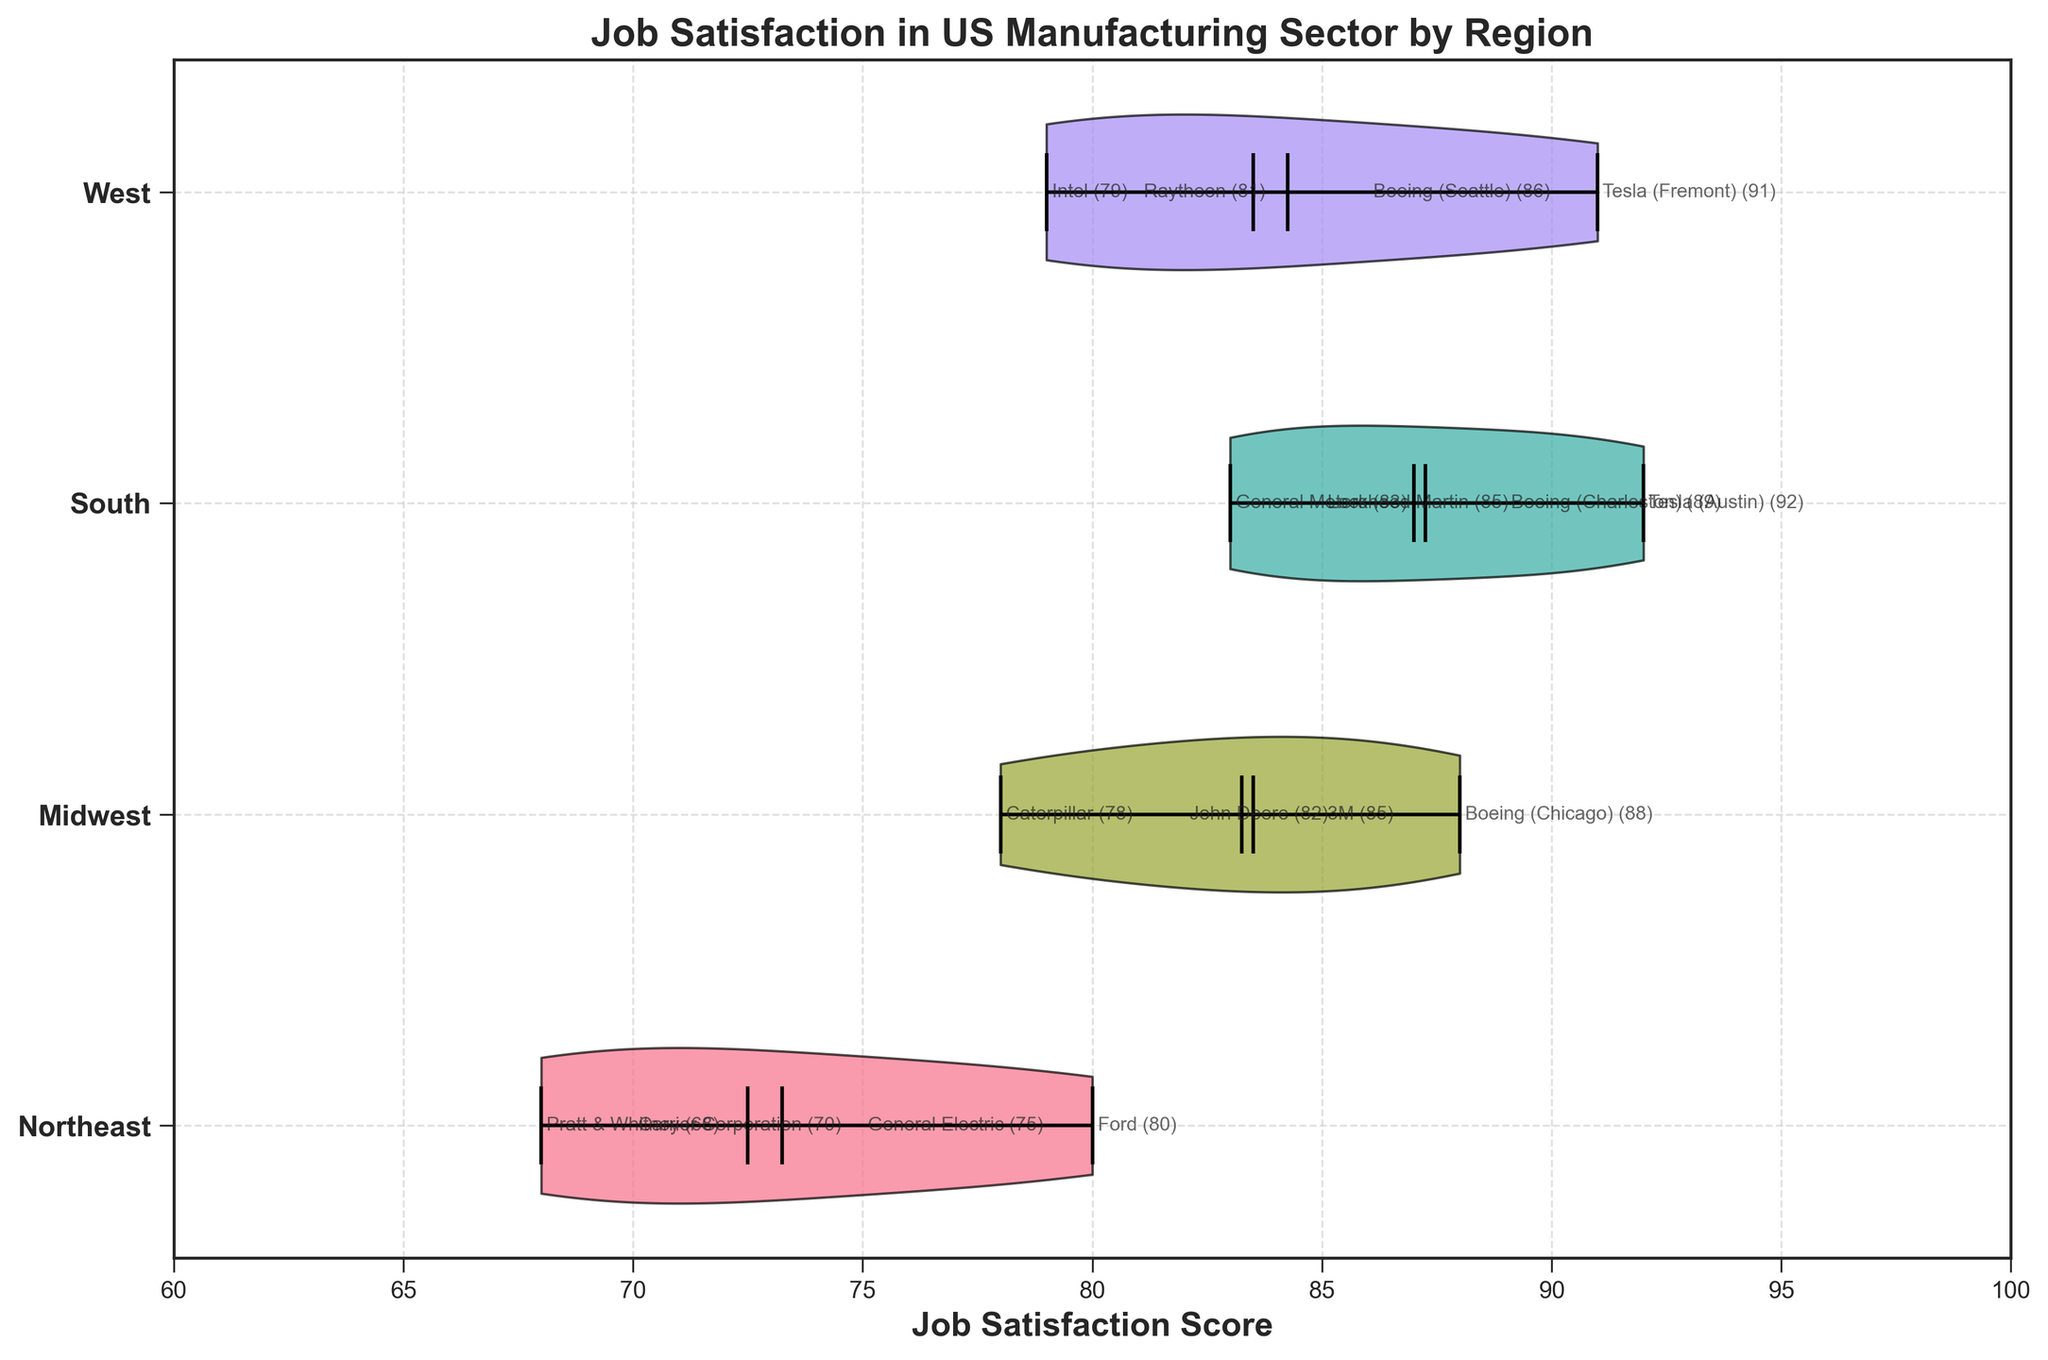what is the title of the chart? The title of the chart is located at the top and provides an overview of what the figure represents.
Answer: Job Satisfaction in US Manufacturing Sector by Region what regions are shown in the chart? The y-axis labels of the chart indicate the names of the regions. These regions are presented as unique identifiers in the chart.
Answer: Northeast, Midwest, South, West which company has the highest job satisfaction score in the South region? Look for the companies listed in the South region and compare their job satisfaction scores. Tesla (Austin) has the highest score.
Answer: Tesla (Austin) what is the range of job satisfaction scores in the Midwest region? Check the horizontal spread of the violin plot section for the Midwest region and find the minimum and maximum scores. The range is from 78 to 88.
Answer: 78 to 88 which region has the lowest median job satisfaction score? Identify the median markers on the violin plots for each region and compare them. The Northeast region shows the lowest median job satisfaction score.
Answer: Northeast which company in the West region has a job satisfaction score close to the mean score of the region? Examine the location of each company's score within the West region's violin plot, focusing on those near the mean marker. Raytheon, with a score of 81, is close to the mean.
Answer: Raytheon how do the extremes of job satisfaction scores in the South compare to those in the Northeast? Check the endpoints of the violin plots for both South and Northeast, noting their relative positions. The South has higher extremes (83 to 92) compared to the Northeast (68 to 80).
Answer: South scores are higher what is the overall trend of job satisfaction scores from East to West regions? Analyze the general placement of job satisfaction scores for each region from left (Northeast) to right (West). There is an increasing trend in job satisfaction from East (Northeast) to South and then slightly decreasing going to West.
Answer: Increasing from Northeast to South, then slightly decreasing to West 